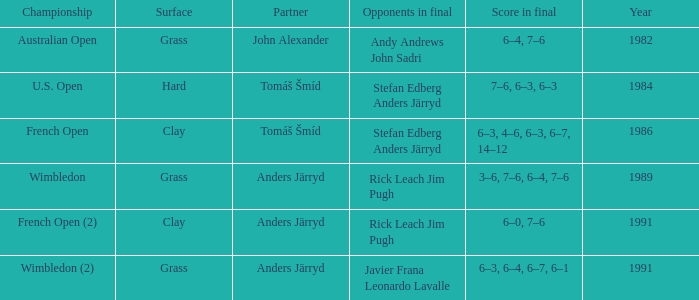What was the final score in 1986? 6–3, 4–6, 6–3, 6–7, 14–12. Would you mind parsing the complete table? {'header': ['Championship', 'Surface', 'Partner', 'Opponents in final', 'Score in final', 'Year'], 'rows': [['Australian Open', 'Grass', 'John Alexander', 'Andy Andrews John Sadri', '6–4, 7–6', '1982'], ['U.S. Open', 'Hard', 'Tomáš Šmíd', 'Stefan Edberg Anders Järryd', '7–6, 6–3, 6–3', '1984'], ['French Open', 'Clay', 'Tomáš Šmíd', 'Stefan Edberg Anders Järryd', '6–3, 4–6, 6–3, 6–7, 14–12', '1986'], ['Wimbledon', 'Grass', 'Anders Järryd', 'Rick Leach Jim Pugh', '3–6, 7–6, 6–4, 7–6', '1989'], ['French Open (2)', 'Clay', 'Anders Järryd', 'Rick Leach Jim Pugh', '6–0, 7–6', '1991'], ['Wimbledon (2)', 'Grass', 'Anders Järryd', 'Javier Frana Leonardo Lavalle', '6–3, 6–4, 6–7, 6–1', '1991']]} 